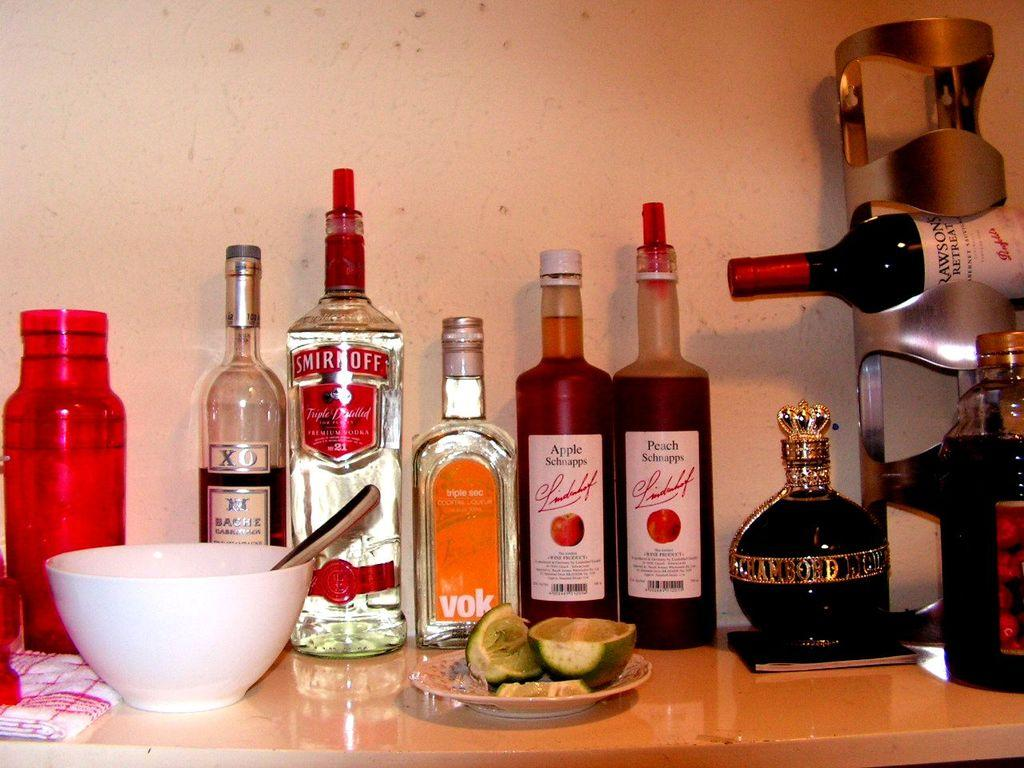<image>
Summarize the visual content of the image. A bottle of Smirnoff and a bottle of Chambord are among the liquors on the table. 